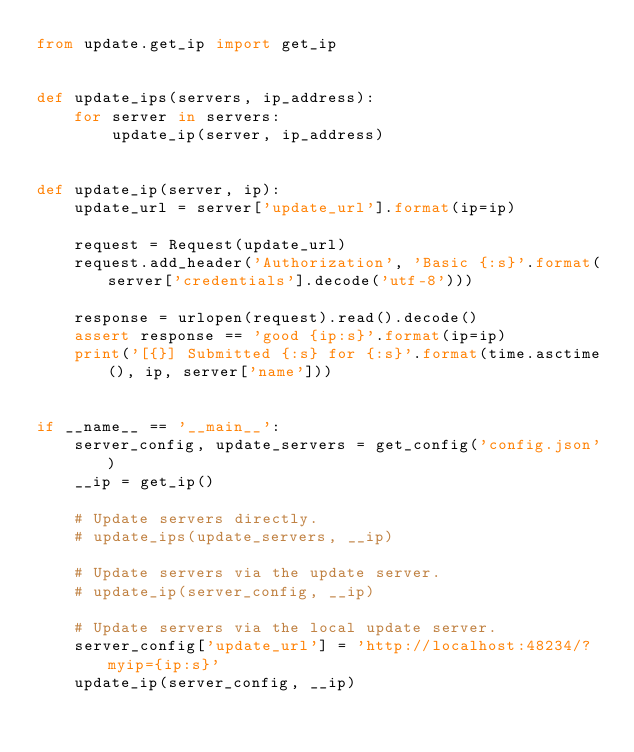<code> <loc_0><loc_0><loc_500><loc_500><_Python_>from update.get_ip import get_ip


def update_ips(servers, ip_address):
    for server in servers:
        update_ip(server, ip_address)


def update_ip(server, ip):
    update_url = server['update_url'].format(ip=ip)

    request = Request(update_url)
    request.add_header('Authorization', 'Basic {:s}'.format(server['credentials'].decode('utf-8')))

    response = urlopen(request).read().decode()
    assert response == 'good {ip:s}'.format(ip=ip)
    print('[{}] Submitted {:s} for {:s}'.format(time.asctime(), ip, server['name']))


if __name__ == '__main__':
    server_config, update_servers = get_config('config.json')
    __ip = get_ip()

    # Update servers directly.
    # update_ips(update_servers, __ip)

    # Update servers via the update server.
    # update_ip(server_config, __ip)

    # Update servers via the local update server.
    server_config['update_url'] = 'http://localhost:48234/?myip={ip:s}'
    update_ip(server_config, __ip)
</code> 